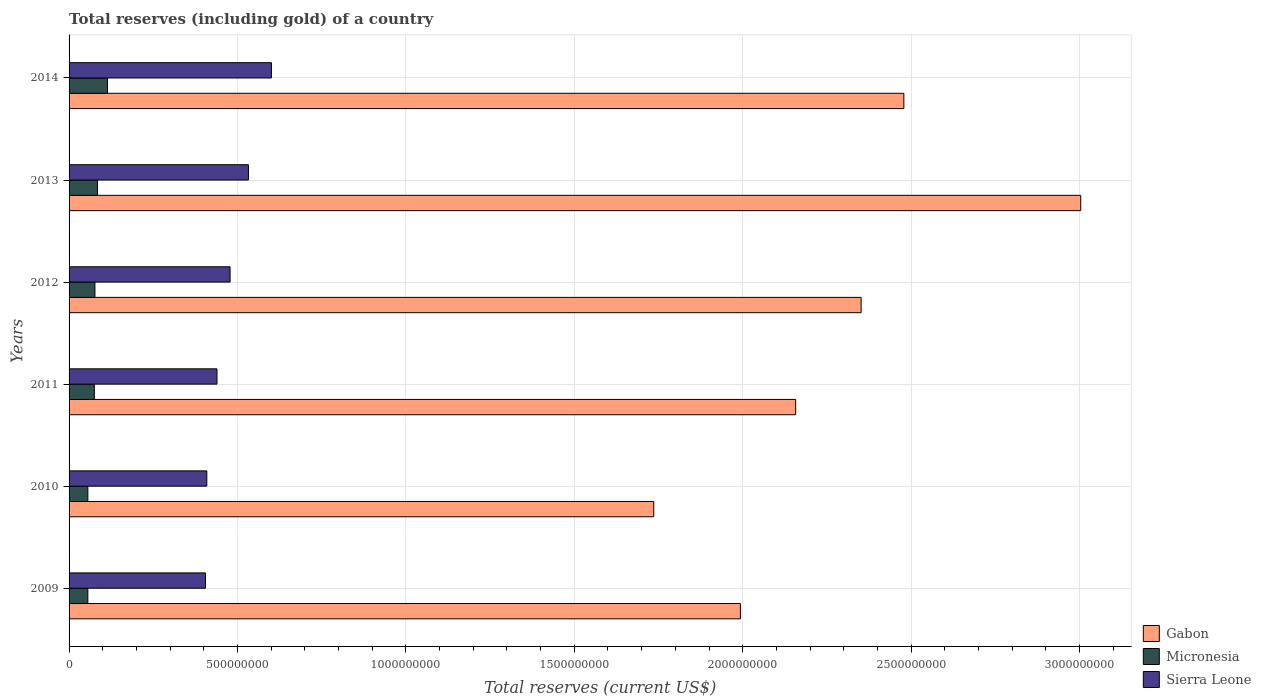How many different coloured bars are there?
Provide a short and direct response. 3. How many groups of bars are there?
Your answer should be compact. 6. Are the number of bars per tick equal to the number of legend labels?
Your response must be concise. Yes. Are the number of bars on each tick of the Y-axis equal?
Your response must be concise. Yes. What is the total reserves (including gold) in Gabon in 2010?
Offer a very short reply. 1.74e+09. Across all years, what is the maximum total reserves (including gold) in Sierra Leone?
Provide a succinct answer. 6.01e+08. Across all years, what is the minimum total reserves (including gold) in Gabon?
Give a very brief answer. 1.74e+09. What is the total total reserves (including gold) in Sierra Leone in the graph?
Offer a terse response. 2.86e+09. What is the difference between the total reserves (including gold) in Micronesia in 2009 and that in 2013?
Offer a very short reply. -2.86e+07. What is the difference between the total reserves (including gold) in Micronesia in 2009 and the total reserves (including gold) in Gabon in 2012?
Provide a succinct answer. -2.30e+09. What is the average total reserves (including gold) in Sierra Leone per year?
Keep it short and to the point. 4.77e+08. In the year 2011, what is the difference between the total reserves (including gold) in Gabon and total reserves (including gold) in Micronesia?
Offer a very short reply. 2.08e+09. In how many years, is the total reserves (including gold) in Sierra Leone greater than 2100000000 US$?
Provide a short and direct response. 0. What is the ratio of the total reserves (including gold) in Sierra Leone in 2010 to that in 2011?
Offer a very short reply. 0.93. Is the total reserves (including gold) in Micronesia in 2009 less than that in 2014?
Provide a short and direct response. Yes. Is the difference between the total reserves (including gold) in Gabon in 2009 and 2010 greater than the difference between the total reserves (including gold) in Micronesia in 2009 and 2010?
Your answer should be very brief. Yes. What is the difference between the highest and the second highest total reserves (including gold) in Gabon?
Offer a terse response. 5.25e+08. What is the difference between the highest and the lowest total reserves (including gold) in Gabon?
Give a very brief answer. 1.27e+09. In how many years, is the total reserves (including gold) in Micronesia greater than the average total reserves (including gold) in Micronesia taken over all years?
Your answer should be compact. 2. Is the sum of the total reserves (including gold) in Micronesia in 2009 and 2011 greater than the maximum total reserves (including gold) in Sierra Leone across all years?
Your answer should be very brief. No. What does the 3rd bar from the top in 2011 represents?
Give a very brief answer. Gabon. What does the 1st bar from the bottom in 2012 represents?
Provide a succinct answer. Gabon. Is it the case that in every year, the sum of the total reserves (including gold) in Gabon and total reserves (including gold) in Micronesia is greater than the total reserves (including gold) in Sierra Leone?
Make the answer very short. Yes. Are all the bars in the graph horizontal?
Your answer should be very brief. Yes. What is the difference between two consecutive major ticks on the X-axis?
Provide a short and direct response. 5.00e+08. Are the values on the major ticks of X-axis written in scientific E-notation?
Your answer should be compact. No. Where does the legend appear in the graph?
Your answer should be very brief. Bottom right. How many legend labels are there?
Offer a terse response. 3. What is the title of the graph?
Provide a succinct answer. Total reserves (including gold) of a country. Does "St. Vincent and the Grenadines" appear as one of the legend labels in the graph?
Provide a succinct answer. No. What is the label or title of the X-axis?
Make the answer very short. Total reserves (current US$). What is the label or title of the Y-axis?
Offer a very short reply. Years. What is the Total reserves (current US$) in Gabon in 2009?
Ensure brevity in your answer.  1.99e+09. What is the Total reserves (current US$) of Micronesia in 2009?
Make the answer very short. 5.57e+07. What is the Total reserves (current US$) of Sierra Leone in 2009?
Offer a very short reply. 4.05e+08. What is the Total reserves (current US$) in Gabon in 2010?
Ensure brevity in your answer.  1.74e+09. What is the Total reserves (current US$) in Micronesia in 2010?
Offer a very short reply. 5.58e+07. What is the Total reserves (current US$) in Sierra Leone in 2010?
Your response must be concise. 4.09e+08. What is the Total reserves (current US$) of Gabon in 2011?
Give a very brief answer. 2.16e+09. What is the Total reserves (current US$) of Micronesia in 2011?
Offer a terse response. 7.51e+07. What is the Total reserves (current US$) of Sierra Leone in 2011?
Give a very brief answer. 4.39e+08. What is the Total reserves (current US$) of Gabon in 2012?
Keep it short and to the point. 2.35e+09. What is the Total reserves (current US$) in Micronesia in 2012?
Make the answer very short. 7.68e+07. What is the Total reserves (current US$) of Sierra Leone in 2012?
Give a very brief answer. 4.78e+08. What is the Total reserves (current US$) in Gabon in 2013?
Your answer should be compact. 3.00e+09. What is the Total reserves (current US$) of Micronesia in 2013?
Provide a short and direct response. 8.43e+07. What is the Total reserves (current US$) of Sierra Leone in 2013?
Your answer should be compact. 5.33e+08. What is the Total reserves (current US$) of Gabon in 2014?
Make the answer very short. 2.48e+09. What is the Total reserves (current US$) of Micronesia in 2014?
Your answer should be very brief. 1.14e+08. What is the Total reserves (current US$) of Sierra Leone in 2014?
Make the answer very short. 6.01e+08. Across all years, what is the maximum Total reserves (current US$) of Gabon?
Provide a short and direct response. 3.00e+09. Across all years, what is the maximum Total reserves (current US$) of Micronesia?
Ensure brevity in your answer.  1.14e+08. Across all years, what is the maximum Total reserves (current US$) of Sierra Leone?
Your answer should be compact. 6.01e+08. Across all years, what is the minimum Total reserves (current US$) in Gabon?
Your response must be concise. 1.74e+09. Across all years, what is the minimum Total reserves (current US$) of Micronesia?
Provide a short and direct response. 5.57e+07. Across all years, what is the minimum Total reserves (current US$) in Sierra Leone?
Offer a very short reply. 4.05e+08. What is the total Total reserves (current US$) of Gabon in the graph?
Provide a succinct answer. 1.37e+1. What is the total Total reserves (current US$) of Micronesia in the graph?
Ensure brevity in your answer.  4.62e+08. What is the total Total reserves (current US$) in Sierra Leone in the graph?
Your response must be concise. 2.86e+09. What is the difference between the Total reserves (current US$) of Gabon in 2009 and that in 2010?
Provide a short and direct response. 2.57e+08. What is the difference between the Total reserves (current US$) in Micronesia in 2009 and that in 2010?
Your answer should be very brief. -4.52e+04. What is the difference between the Total reserves (current US$) of Sierra Leone in 2009 and that in 2010?
Your answer should be compact. -4.01e+06. What is the difference between the Total reserves (current US$) of Gabon in 2009 and that in 2011?
Provide a succinct answer. -1.64e+08. What is the difference between the Total reserves (current US$) of Micronesia in 2009 and that in 2011?
Give a very brief answer. -1.93e+07. What is the difference between the Total reserves (current US$) in Sierra Leone in 2009 and that in 2011?
Give a very brief answer. -3.42e+07. What is the difference between the Total reserves (current US$) in Gabon in 2009 and that in 2012?
Keep it short and to the point. -3.58e+08. What is the difference between the Total reserves (current US$) in Micronesia in 2009 and that in 2012?
Offer a terse response. -2.11e+07. What is the difference between the Total reserves (current US$) of Sierra Leone in 2009 and that in 2012?
Provide a short and direct response. -7.30e+07. What is the difference between the Total reserves (current US$) in Gabon in 2009 and that in 2013?
Offer a terse response. -1.01e+09. What is the difference between the Total reserves (current US$) in Micronesia in 2009 and that in 2013?
Make the answer very short. -2.86e+07. What is the difference between the Total reserves (current US$) of Sierra Leone in 2009 and that in 2013?
Offer a very short reply. -1.28e+08. What is the difference between the Total reserves (current US$) in Gabon in 2009 and that in 2014?
Give a very brief answer. -4.85e+08. What is the difference between the Total reserves (current US$) of Micronesia in 2009 and that in 2014?
Keep it short and to the point. -5.84e+07. What is the difference between the Total reserves (current US$) of Sierra Leone in 2009 and that in 2014?
Offer a very short reply. -1.96e+08. What is the difference between the Total reserves (current US$) of Gabon in 2010 and that in 2011?
Make the answer very short. -4.21e+08. What is the difference between the Total reserves (current US$) in Micronesia in 2010 and that in 2011?
Your answer should be very brief. -1.93e+07. What is the difference between the Total reserves (current US$) in Sierra Leone in 2010 and that in 2011?
Offer a terse response. -3.02e+07. What is the difference between the Total reserves (current US$) of Gabon in 2010 and that in 2012?
Keep it short and to the point. -6.16e+08. What is the difference between the Total reserves (current US$) of Micronesia in 2010 and that in 2012?
Ensure brevity in your answer.  -2.10e+07. What is the difference between the Total reserves (current US$) in Sierra Leone in 2010 and that in 2012?
Offer a terse response. -6.90e+07. What is the difference between the Total reserves (current US$) in Gabon in 2010 and that in 2013?
Give a very brief answer. -1.27e+09. What is the difference between the Total reserves (current US$) of Micronesia in 2010 and that in 2013?
Your answer should be very brief. -2.86e+07. What is the difference between the Total reserves (current US$) of Sierra Leone in 2010 and that in 2013?
Provide a succinct answer. -1.24e+08. What is the difference between the Total reserves (current US$) in Gabon in 2010 and that in 2014?
Keep it short and to the point. -7.43e+08. What is the difference between the Total reserves (current US$) of Micronesia in 2010 and that in 2014?
Provide a succinct answer. -5.84e+07. What is the difference between the Total reserves (current US$) in Sierra Leone in 2010 and that in 2014?
Your response must be concise. -1.92e+08. What is the difference between the Total reserves (current US$) in Gabon in 2011 and that in 2012?
Provide a succinct answer. -1.94e+08. What is the difference between the Total reserves (current US$) in Micronesia in 2011 and that in 2012?
Offer a terse response. -1.73e+06. What is the difference between the Total reserves (current US$) of Sierra Leone in 2011 and that in 2012?
Make the answer very short. -3.89e+07. What is the difference between the Total reserves (current US$) of Gabon in 2011 and that in 2013?
Offer a terse response. -8.46e+08. What is the difference between the Total reserves (current US$) of Micronesia in 2011 and that in 2013?
Offer a very short reply. -9.28e+06. What is the difference between the Total reserves (current US$) in Sierra Leone in 2011 and that in 2013?
Ensure brevity in your answer.  -9.34e+07. What is the difference between the Total reserves (current US$) in Gabon in 2011 and that in 2014?
Offer a terse response. -3.21e+08. What is the difference between the Total reserves (current US$) of Micronesia in 2011 and that in 2014?
Ensure brevity in your answer.  -3.91e+07. What is the difference between the Total reserves (current US$) in Sierra Leone in 2011 and that in 2014?
Offer a terse response. -1.62e+08. What is the difference between the Total reserves (current US$) of Gabon in 2012 and that in 2013?
Provide a succinct answer. -6.52e+08. What is the difference between the Total reserves (current US$) in Micronesia in 2012 and that in 2013?
Make the answer very short. -7.55e+06. What is the difference between the Total reserves (current US$) of Sierra Leone in 2012 and that in 2013?
Offer a very short reply. -5.46e+07. What is the difference between the Total reserves (current US$) in Gabon in 2012 and that in 2014?
Provide a succinct answer. -1.27e+08. What is the difference between the Total reserves (current US$) in Micronesia in 2012 and that in 2014?
Ensure brevity in your answer.  -3.73e+07. What is the difference between the Total reserves (current US$) in Sierra Leone in 2012 and that in 2014?
Keep it short and to the point. -1.23e+08. What is the difference between the Total reserves (current US$) in Gabon in 2013 and that in 2014?
Give a very brief answer. 5.25e+08. What is the difference between the Total reserves (current US$) in Micronesia in 2013 and that in 2014?
Make the answer very short. -2.98e+07. What is the difference between the Total reserves (current US$) in Sierra Leone in 2013 and that in 2014?
Offer a terse response. -6.82e+07. What is the difference between the Total reserves (current US$) in Gabon in 2009 and the Total reserves (current US$) in Micronesia in 2010?
Give a very brief answer. 1.94e+09. What is the difference between the Total reserves (current US$) of Gabon in 2009 and the Total reserves (current US$) of Sierra Leone in 2010?
Your response must be concise. 1.58e+09. What is the difference between the Total reserves (current US$) in Micronesia in 2009 and the Total reserves (current US$) in Sierra Leone in 2010?
Your answer should be compact. -3.53e+08. What is the difference between the Total reserves (current US$) of Gabon in 2009 and the Total reserves (current US$) of Micronesia in 2011?
Provide a short and direct response. 1.92e+09. What is the difference between the Total reserves (current US$) of Gabon in 2009 and the Total reserves (current US$) of Sierra Leone in 2011?
Ensure brevity in your answer.  1.55e+09. What is the difference between the Total reserves (current US$) of Micronesia in 2009 and the Total reserves (current US$) of Sierra Leone in 2011?
Keep it short and to the point. -3.83e+08. What is the difference between the Total reserves (current US$) of Gabon in 2009 and the Total reserves (current US$) of Micronesia in 2012?
Make the answer very short. 1.92e+09. What is the difference between the Total reserves (current US$) of Gabon in 2009 and the Total reserves (current US$) of Sierra Leone in 2012?
Your response must be concise. 1.52e+09. What is the difference between the Total reserves (current US$) in Micronesia in 2009 and the Total reserves (current US$) in Sierra Leone in 2012?
Ensure brevity in your answer.  -4.22e+08. What is the difference between the Total reserves (current US$) of Gabon in 2009 and the Total reserves (current US$) of Micronesia in 2013?
Your response must be concise. 1.91e+09. What is the difference between the Total reserves (current US$) of Gabon in 2009 and the Total reserves (current US$) of Sierra Leone in 2013?
Make the answer very short. 1.46e+09. What is the difference between the Total reserves (current US$) of Micronesia in 2009 and the Total reserves (current US$) of Sierra Leone in 2013?
Give a very brief answer. -4.77e+08. What is the difference between the Total reserves (current US$) in Gabon in 2009 and the Total reserves (current US$) in Micronesia in 2014?
Provide a succinct answer. 1.88e+09. What is the difference between the Total reserves (current US$) in Gabon in 2009 and the Total reserves (current US$) in Sierra Leone in 2014?
Your response must be concise. 1.39e+09. What is the difference between the Total reserves (current US$) in Micronesia in 2009 and the Total reserves (current US$) in Sierra Leone in 2014?
Offer a terse response. -5.45e+08. What is the difference between the Total reserves (current US$) of Gabon in 2010 and the Total reserves (current US$) of Micronesia in 2011?
Provide a short and direct response. 1.66e+09. What is the difference between the Total reserves (current US$) of Gabon in 2010 and the Total reserves (current US$) of Sierra Leone in 2011?
Your answer should be very brief. 1.30e+09. What is the difference between the Total reserves (current US$) in Micronesia in 2010 and the Total reserves (current US$) in Sierra Leone in 2011?
Make the answer very short. -3.83e+08. What is the difference between the Total reserves (current US$) in Gabon in 2010 and the Total reserves (current US$) in Micronesia in 2012?
Give a very brief answer. 1.66e+09. What is the difference between the Total reserves (current US$) of Gabon in 2010 and the Total reserves (current US$) of Sierra Leone in 2012?
Offer a terse response. 1.26e+09. What is the difference between the Total reserves (current US$) in Micronesia in 2010 and the Total reserves (current US$) in Sierra Leone in 2012?
Give a very brief answer. -4.22e+08. What is the difference between the Total reserves (current US$) in Gabon in 2010 and the Total reserves (current US$) in Micronesia in 2013?
Offer a terse response. 1.65e+09. What is the difference between the Total reserves (current US$) of Gabon in 2010 and the Total reserves (current US$) of Sierra Leone in 2013?
Provide a succinct answer. 1.20e+09. What is the difference between the Total reserves (current US$) in Micronesia in 2010 and the Total reserves (current US$) in Sierra Leone in 2013?
Provide a short and direct response. -4.77e+08. What is the difference between the Total reserves (current US$) in Gabon in 2010 and the Total reserves (current US$) in Micronesia in 2014?
Give a very brief answer. 1.62e+09. What is the difference between the Total reserves (current US$) of Gabon in 2010 and the Total reserves (current US$) of Sierra Leone in 2014?
Provide a succinct answer. 1.14e+09. What is the difference between the Total reserves (current US$) in Micronesia in 2010 and the Total reserves (current US$) in Sierra Leone in 2014?
Provide a succinct answer. -5.45e+08. What is the difference between the Total reserves (current US$) in Gabon in 2011 and the Total reserves (current US$) in Micronesia in 2012?
Offer a very short reply. 2.08e+09. What is the difference between the Total reserves (current US$) of Gabon in 2011 and the Total reserves (current US$) of Sierra Leone in 2012?
Offer a terse response. 1.68e+09. What is the difference between the Total reserves (current US$) in Micronesia in 2011 and the Total reserves (current US$) in Sierra Leone in 2012?
Your answer should be very brief. -4.03e+08. What is the difference between the Total reserves (current US$) of Gabon in 2011 and the Total reserves (current US$) of Micronesia in 2013?
Offer a terse response. 2.07e+09. What is the difference between the Total reserves (current US$) in Gabon in 2011 and the Total reserves (current US$) in Sierra Leone in 2013?
Keep it short and to the point. 1.62e+09. What is the difference between the Total reserves (current US$) in Micronesia in 2011 and the Total reserves (current US$) in Sierra Leone in 2013?
Offer a very short reply. -4.57e+08. What is the difference between the Total reserves (current US$) of Gabon in 2011 and the Total reserves (current US$) of Micronesia in 2014?
Your answer should be compact. 2.04e+09. What is the difference between the Total reserves (current US$) of Gabon in 2011 and the Total reserves (current US$) of Sierra Leone in 2014?
Give a very brief answer. 1.56e+09. What is the difference between the Total reserves (current US$) in Micronesia in 2011 and the Total reserves (current US$) in Sierra Leone in 2014?
Provide a succinct answer. -5.26e+08. What is the difference between the Total reserves (current US$) in Gabon in 2012 and the Total reserves (current US$) in Micronesia in 2013?
Make the answer very short. 2.27e+09. What is the difference between the Total reserves (current US$) in Gabon in 2012 and the Total reserves (current US$) in Sierra Leone in 2013?
Offer a terse response. 1.82e+09. What is the difference between the Total reserves (current US$) in Micronesia in 2012 and the Total reserves (current US$) in Sierra Leone in 2013?
Your response must be concise. -4.56e+08. What is the difference between the Total reserves (current US$) in Gabon in 2012 and the Total reserves (current US$) in Micronesia in 2014?
Keep it short and to the point. 2.24e+09. What is the difference between the Total reserves (current US$) in Gabon in 2012 and the Total reserves (current US$) in Sierra Leone in 2014?
Provide a short and direct response. 1.75e+09. What is the difference between the Total reserves (current US$) in Micronesia in 2012 and the Total reserves (current US$) in Sierra Leone in 2014?
Keep it short and to the point. -5.24e+08. What is the difference between the Total reserves (current US$) of Gabon in 2013 and the Total reserves (current US$) of Micronesia in 2014?
Give a very brief answer. 2.89e+09. What is the difference between the Total reserves (current US$) of Gabon in 2013 and the Total reserves (current US$) of Sierra Leone in 2014?
Provide a short and direct response. 2.40e+09. What is the difference between the Total reserves (current US$) of Micronesia in 2013 and the Total reserves (current US$) of Sierra Leone in 2014?
Your answer should be very brief. -5.16e+08. What is the average Total reserves (current US$) in Gabon per year?
Make the answer very short. 2.29e+09. What is the average Total reserves (current US$) of Micronesia per year?
Make the answer very short. 7.70e+07. What is the average Total reserves (current US$) of Sierra Leone per year?
Provide a short and direct response. 4.77e+08. In the year 2009, what is the difference between the Total reserves (current US$) in Gabon and Total reserves (current US$) in Micronesia?
Give a very brief answer. 1.94e+09. In the year 2009, what is the difference between the Total reserves (current US$) in Gabon and Total reserves (current US$) in Sierra Leone?
Make the answer very short. 1.59e+09. In the year 2009, what is the difference between the Total reserves (current US$) of Micronesia and Total reserves (current US$) of Sierra Leone?
Your answer should be very brief. -3.49e+08. In the year 2010, what is the difference between the Total reserves (current US$) in Gabon and Total reserves (current US$) in Micronesia?
Ensure brevity in your answer.  1.68e+09. In the year 2010, what is the difference between the Total reserves (current US$) in Gabon and Total reserves (current US$) in Sierra Leone?
Offer a very short reply. 1.33e+09. In the year 2010, what is the difference between the Total reserves (current US$) in Micronesia and Total reserves (current US$) in Sierra Leone?
Provide a succinct answer. -3.53e+08. In the year 2011, what is the difference between the Total reserves (current US$) in Gabon and Total reserves (current US$) in Micronesia?
Ensure brevity in your answer.  2.08e+09. In the year 2011, what is the difference between the Total reserves (current US$) in Gabon and Total reserves (current US$) in Sierra Leone?
Keep it short and to the point. 1.72e+09. In the year 2011, what is the difference between the Total reserves (current US$) in Micronesia and Total reserves (current US$) in Sierra Leone?
Provide a short and direct response. -3.64e+08. In the year 2012, what is the difference between the Total reserves (current US$) of Gabon and Total reserves (current US$) of Micronesia?
Your response must be concise. 2.27e+09. In the year 2012, what is the difference between the Total reserves (current US$) in Gabon and Total reserves (current US$) in Sierra Leone?
Your response must be concise. 1.87e+09. In the year 2012, what is the difference between the Total reserves (current US$) in Micronesia and Total reserves (current US$) in Sierra Leone?
Your answer should be compact. -4.01e+08. In the year 2013, what is the difference between the Total reserves (current US$) in Gabon and Total reserves (current US$) in Micronesia?
Provide a short and direct response. 2.92e+09. In the year 2013, what is the difference between the Total reserves (current US$) in Gabon and Total reserves (current US$) in Sierra Leone?
Provide a short and direct response. 2.47e+09. In the year 2013, what is the difference between the Total reserves (current US$) in Micronesia and Total reserves (current US$) in Sierra Leone?
Your answer should be very brief. -4.48e+08. In the year 2014, what is the difference between the Total reserves (current US$) of Gabon and Total reserves (current US$) of Micronesia?
Offer a very short reply. 2.36e+09. In the year 2014, what is the difference between the Total reserves (current US$) of Gabon and Total reserves (current US$) of Sierra Leone?
Keep it short and to the point. 1.88e+09. In the year 2014, what is the difference between the Total reserves (current US$) of Micronesia and Total reserves (current US$) of Sierra Leone?
Provide a succinct answer. -4.87e+08. What is the ratio of the Total reserves (current US$) in Gabon in 2009 to that in 2010?
Provide a succinct answer. 1.15. What is the ratio of the Total reserves (current US$) in Sierra Leone in 2009 to that in 2010?
Provide a succinct answer. 0.99. What is the ratio of the Total reserves (current US$) of Gabon in 2009 to that in 2011?
Ensure brevity in your answer.  0.92. What is the ratio of the Total reserves (current US$) of Micronesia in 2009 to that in 2011?
Your answer should be compact. 0.74. What is the ratio of the Total reserves (current US$) in Sierra Leone in 2009 to that in 2011?
Provide a succinct answer. 0.92. What is the ratio of the Total reserves (current US$) of Gabon in 2009 to that in 2012?
Offer a terse response. 0.85. What is the ratio of the Total reserves (current US$) of Micronesia in 2009 to that in 2012?
Keep it short and to the point. 0.73. What is the ratio of the Total reserves (current US$) in Sierra Leone in 2009 to that in 2012?
Provide a succinct answer. 0.85. What is the ratio of the Total reserves (current US$) of Gabon in 2009 to that in 2013?
Offer a very short reply. 0.66. What is the ratio of the Total reserves (current US$) of Micronesia in 2009 to that in 2013?
Your answer should be compact. 0.66. What is the ratio of the Total reserves (current US$) of Sierra Leone in 2009 to that in 2013?
Your answer should be compact. 0.76. What is the ratio of the Total reserves (current US$) of Gabon in 2009 to that in 2014?
Your answer should be very brief. 0.8. What is the ratio of the Total reserves (current US$) of Micronesia in 2009 to that in 2014?
Your answer should be very brief. 0.49. What is the ratio of the Total reserves (current US$) of Sierra Leone in 2009 to that in 2014?
Your answer should be very brief. 0.67. What is the ratio of the Total reserves (current US$) in Gabon in 2010 to that in 2011?
Give a very brief answer. 0.8. What is the ratio of the Total reserves (current US$) in Micronesia in 2010 to that in 2011?
Ensure brevity in your answer.  0.74. What is the ratio of the Total reserves (current US$) of Sierra Leone in 2010 to that in 2011?
Offer a terse response. 0.93. What is the ratio of the Total reserves (current US$) in Gabon in 2010 to that in 2012?
Your answer should be compact. 0.74. What is the ratio of the Total reserves (current US$) of Micronesia in 2010 to that in 2012?
Provide a short and direct response. 0.73. What is the ratio of the Total reserves (current US$) of Sierra Leone in 2010 to that in 2012?
Your response must be concise. 0.86. What is the ratio of the Total reserves (current US$) in Gabon in 2010 to that in 2013?
Make the answer very short. 0.58. What is the ratio of the Total reserves (current US$) in Micronesia in 2010 to that in 2013?
Offer a terse response. 0.66. What is the ratio of the Total reserves (current US$) of Sierra Leone in 2010 to that in 2013?
Make the answer very short. 0.77. What is the ratio of the Total reserves (current US$) in Gabon in 2010 to that in 2014?
Make the answer very short. 0.7. What is the ratio of the Total reserves (current US$) of Micronesia in 2010 to that in 2014?
Your answer should be compact. 0.49. What is the ratio of the Total reserves (current US$) of Sierra Leone in 2010 to that in 2014?
Keep it short and to the point. 0.68. What is the ratio of the Total reserves (current US$) of Gabon in 2011 to that in 2012?
Ensure brevity in your answer.  0.92. What is the ratio of the Total reserves (current US$) of Micronesia in 2011 to that in 2012?
Provide a succinct answer. 0.98. What is the ratio of the Total reserves (current US$) in Sierra Leone in 2011 to that in 2012?
Provide a succinct answer. 0.92. What is the ratio of the Total reserves (current US$) in Gabon in 2011 to that in 2013?
Offer a terse response. 0.72. What is the ratio of the Total reserves (current US$) in Micronesia in 2011 to that in 2013?
Provide a short and direct response. 0.89. What is the ratio of the Total reserves (current US$) of Sierra Leone in 2011 to that in 2013?
Provide a succinct answer. 0.82. What is the ratio of the Total reserves (current US$) in Gabon in 2011 to that in 2014?
Your answer should be compact. 0.87. What is the ratio of the Total reserves (current US$) of Micronesia in 2011 to that in 2014?
Your answer should be compact. 0.66. What is the ratio of the Total reserves (current US$) in Sierra Leone in 2011 to that in 2014?
Your answer should be very brief. 0.73. What is the ratio of the Total reserves (current US$) in Gabon in 2012 to that in 2013?
Your answer should be compact. 0.78. What is the ratio of the Total reserves (current US$) in Micronesia in 2012 to that in 2013?
Offer a very short reply. 0.91. What is the ratio of the Total reserves (current US$) of Sierra Leone in 2012 to that in 2013?
Offer a very short reply. 0.9. What is the ratio of the Total reserves (current US$) in Gabon in 2012 to that in 2014?
Give a very brief answer. 0.95. What is the ratio of the Total reserves (current US$) in Micronesia in 2012 to that in 2014?
Make the answer very short. 0.67. What is the ratio of the Total reserves (current US$) in Sierra Leone in 2012 to that in 2014?
Keep it short and to the point. 0.8. What is the ratio of the Total reserves (current US$) of Gabon in 2013 to that in 2014?
Make the answer very short. 1.21. What is the ratio of the Total reserves (current US$) of Micronesia in 2013 to that in 2014?
Your response must be concise. 0.74. What is the ratio of the Total reserves (current US$) in Sierra Leone in 2013 to that in 2014?
Offer a terse response. 0.89. What is the difference between the highest and the second highest Total reserves (current US$) of Gabon?
Your answer should be compact. 5.25e+08. What is the difference between the highest and the second highest Total reserves (current US$) in Micronesia?
Make the answer very short. 2.98e+07. What is the difference between the highest and the second highest Total reserves (current US$) of Sierra Leone?
Your answer should be very brief. 6.82e+07. What is the difference between the highest and the lowest Total reserves (current US$) in Gabon?
Offer a very short reply. 1.27e+09. What is the difference between the highest and the lowest Total reserves (current US$) in Micronesia?
Ensure brevity in your answer.  5.84e+07. What is the difference between the highest and the lowest Total reserves (current US$) in Sierra Leone?
Provide a short and direct response. 1.96e+08. 